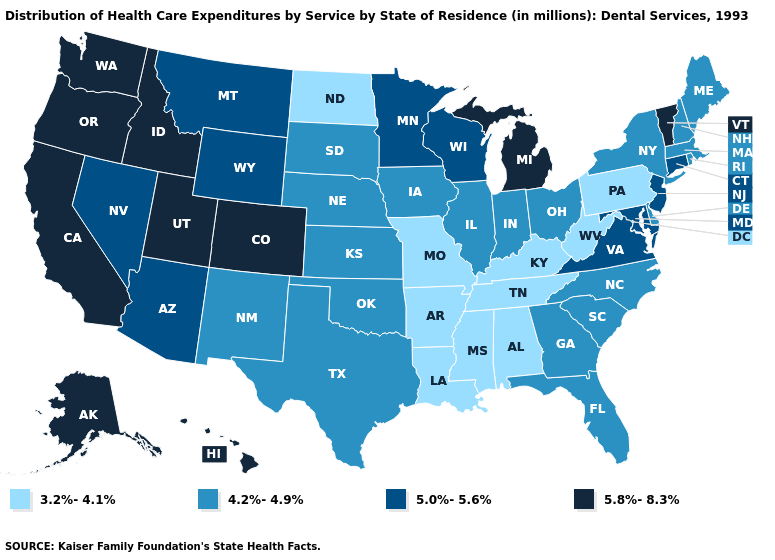What is the value of Louisiana?
Keep it brief. 3.2%-4.1%. What is the value of Utah?
Keep it brief. 5.8%-8.3%. How many symbols are there in the legend?
Be succinct. 4. What is the highest value in states that border Georgia?
Answer briefly. 4.2%-4.9%. Is the legend a continuous bar?
Concise answer only. No. Name the states that have a value in the range 4.2%-4.9%?
Answer briefly. Delaware, Florida, Georgia, Illinois, Indiana, Iowa, Kansas, Maine, Massachusetts, Nebraska, New Hampshire, New Mexico, New York, North Carolina, Ohio, Oklahoma, Rhode Island, South Carolina, South Dakota, Texas. Name the states that have a value in the range 5.0%-5.6%?
Short answer required. Arizona, Connecticut, Maryland, Minnesota, Montana, Nevada, New Jersey, Virginia, Wisconsin, Wyoming. Does Vermont have a higher value than Georgia?
Answer briefly. Yes. Name the states that have a value in the range 4.2%-4.9%?
Concise answer only. Delaware, Florida, Georgia, Illinois, Indiana, Iowa, Kansas, Maine, Massachusetts, Nebraska, New Hampshire, New Mexico, New York, North Carolina, Ohio, Oklahoma, Rhode Island, South Carolina, South Dakota, Texas. What is the highest value in states that border Nebraska?
Keep it brief. 5.8%-8.3%. Which states hav the highest value in the South?
Keep it brief. Maryland, Virginia. Name the states that have a value in the range 5.0%-5.6%?
Keep it brief. Arizona, Connecticut, Maryland, Minnesota, Montana, Nevada, New Jersey, Virginia, Wisconsin, Wyoming. What is the lowest value in states that border North Dakota?
Quick response, please. 4.2%-4.9%. What is the highest value in the South ?
Write a very short answer. 5.0%-5.6%. Does North Dakota have the lowest value in the USA?
Be succinct. Yes. 